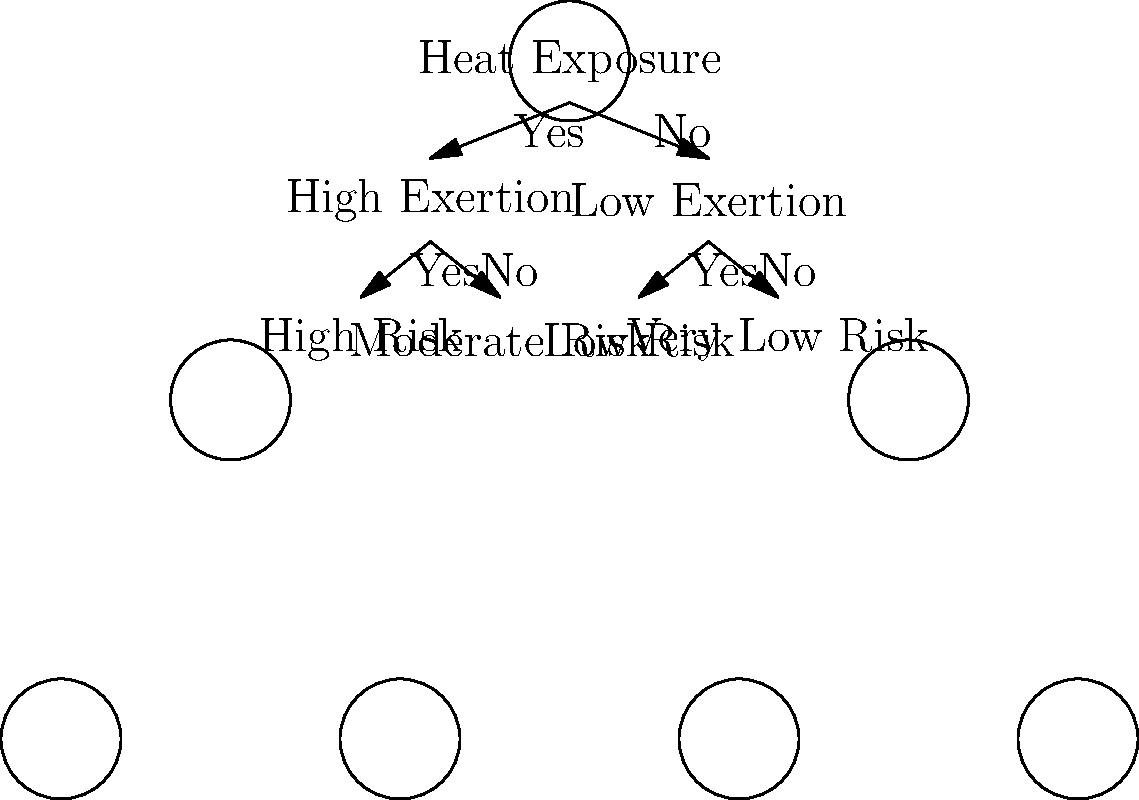In a military training exercise, you are tasked with assessing the risk of heat-related illnesses among soldiers. Using the decision tree diagram provided, what combination of factors would result in a "Moderate Risk" classification for heat-related illness? To determine the combination of factors that result in a "Moderate Risk" classification for heat-related illness, we need to follow the decision tree from top to bottom:

1. Start at the root node "Heat Exposure".
2. Follow the "Yes" branch, indicating that there is heat exposure.
3. This leads to the "High Exertion" node.
4. From here, follow the "No" branch, indicating that the level of exertion is not high.
5. This path leads to the "Moderate Risk" classification.

Therefore, the combination of factors that results in a "Moderate Risk" classification is:
- Presence of heat exposure (Yes)
- Absence of high exertion (No)

This scenario might represent a situation where soldiers are exposed to high temperatures but are not engaging in physically demanding activities.
Answer: Heat exposure present, high exertion absent 